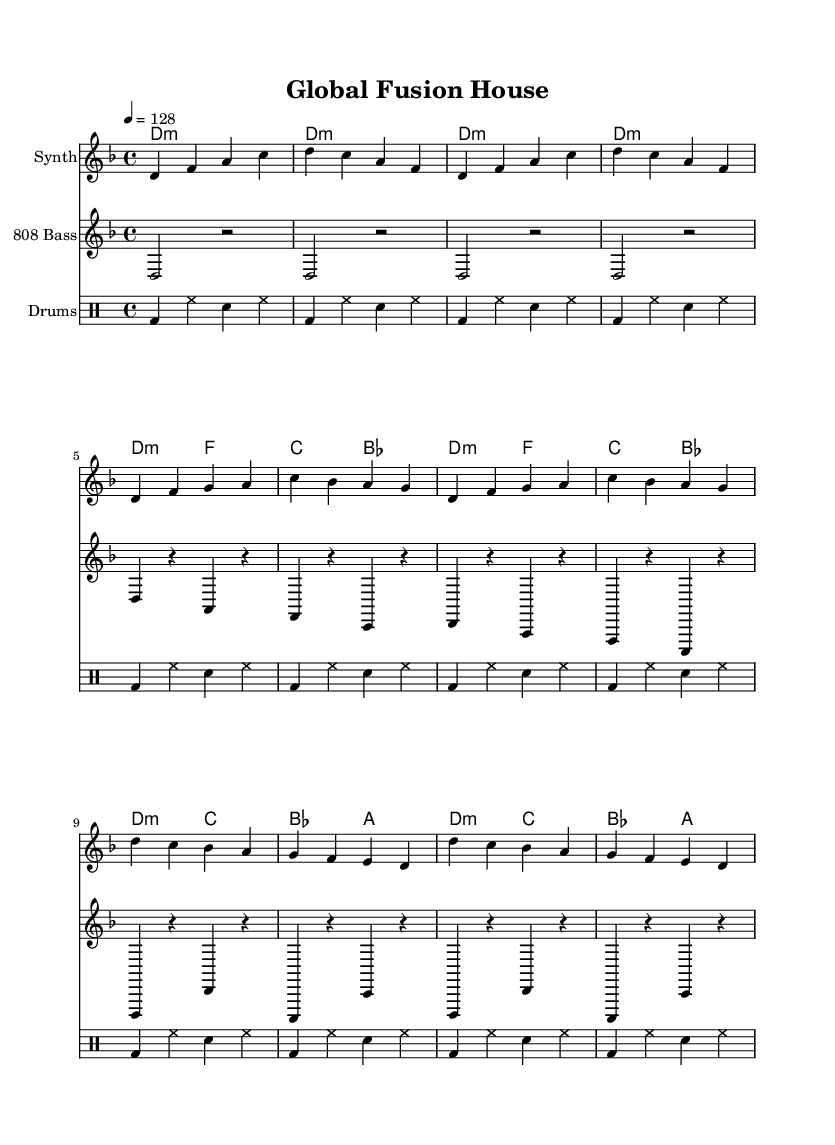What is the key signature of this music? The key signature is D minor, which is indicated by one flat (B flat).
Answer: D minor What is the time signature of this music? The time signature is 4/4, which allows for four beats per measure.
Answer: 4/4 What is the tempo marking of this music? The tempo marking is quarter note equals 128 beats per minute, indicating a fast tempo.
Answer: 128 How many different instrumental parts are there in this piece? There are four different instrumental parts: Synth, Sitar, 808 Bass, and Drums.
Answer: Four What chords are predominantly used in this house track? The predominant chords are D minor and variations of it, as indicated in the harmonies section.
Answer: D minor How many measures are there in the melody section? The melody section consists of eight measures, grouping the music into two sets of four measures each.
Answer: Eight What is the main characteristic of the bass part in this track? The bass part features a steady rhythm and utilizes a deep 808 bass sound, typical for house music.
Answer: Steady, deep 808 bass 